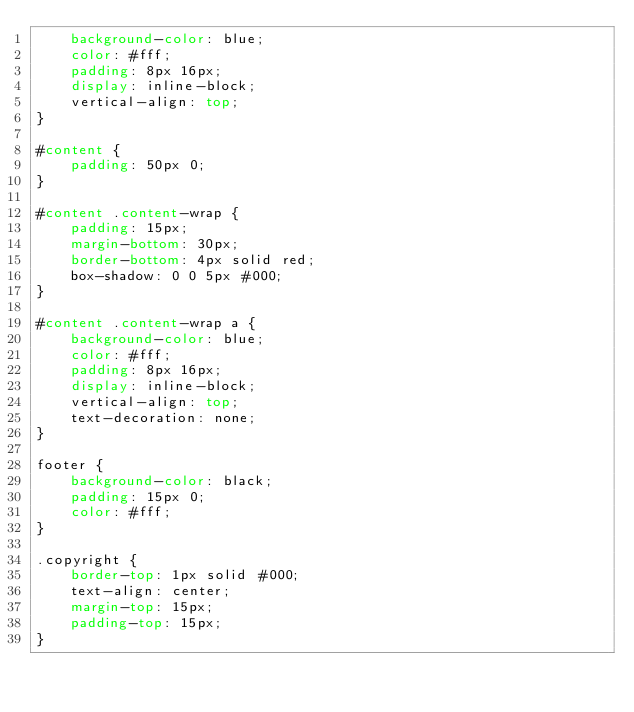<code> <loc_0><loc_0><loc_500><loc_500><_CSS_>    background-color: blue;
    color: #fff;
    padding: 8px 16px;
    display: inline-block;
    vertical-align: top;
}

#content {
    padding: 50px 0;
}

#content .content-wrap {
    padding: 15px;
    margin-bottom: 30px;
    border-bottom: 4px solid red;
    box-shadow: 0 0 5px #000;
}

#content .content-wrap a {
    background-color: blue;
    color: #fff;
    padding: 8px 16px;
    display: inline-block;
    vertical-align: top;
    text-decoration: none;
}

footer {
    background-color: black;
    padding: 15px 0;
    color: #fff;
}

.copyright {
    border-top: 1px solid #000;
    text-align: center;
    margin-top: 15px;
    padding-top: 15px;
}
</code> 